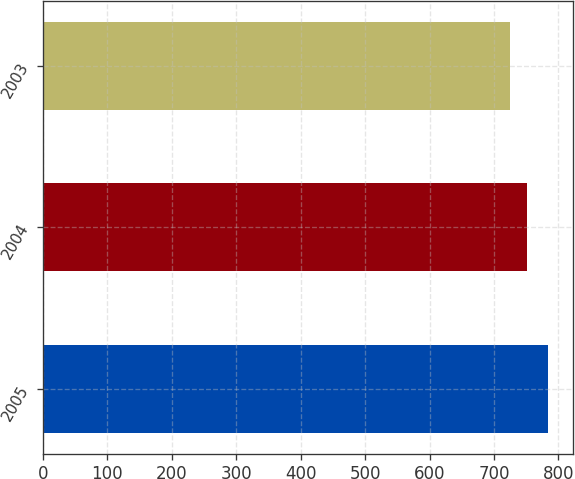Convert chart. <chart><loc_0><loc_0><loc_500><loc_500><bar_chart><fcel>2005<fcel>2004<fcel>2003<nl><fcel>783.9<fcel>751.9<fcel>724.2<nl></chart> 